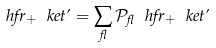Convert formula to latex. <formula><loc_0><loc_0><loc_500><loc_500>\ h f r _ { + } \ k e t { \varphi } = \sum _ { \gamma } { \mathcal { P } _ { \gamma } \ h f r _ { + } \ k e t { \varphi } }</formula> 